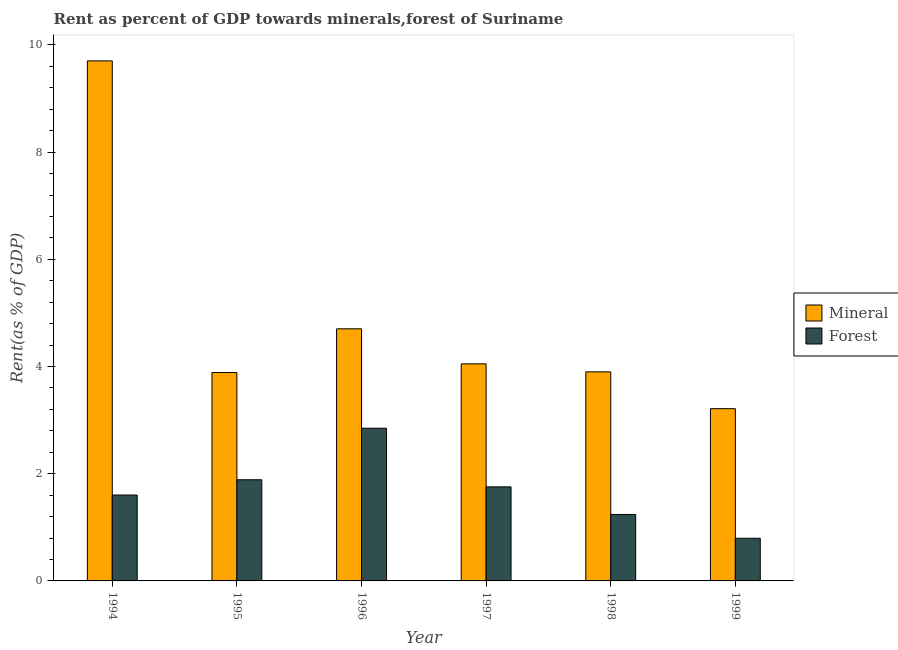How many different coloured bars are there?
Provide a succinct answer. 2. Are the number of bars per tick equal to the number of legend labels?
Your response must be concise. Yes. Are the number of bars on each tick of the X-axis equal?
Provide a succinct answer. Yes. How many bars are there on the 5th tick from the left?
Offer a very short reply. 2. How many bars are there on the 5th tick from the right?
Provide a short and direct response. 2. In how many cases, is the number of bars for a given year not equal to the number of legend labels?
Your response must be concise. 0. What is the forest rent in 1997?
Provide a short and direct response. 1.75. Across all years, what is the maximum mineral rent?
Your answer should be very brief. 9.7. Across all years, what is the minimum mineral rent?
Provide a succinct answer. 3.21. In which year was the forest rent minimum?
Your answer should be very brief. 1999. What is the total forest rent in the graph?
Offer a terse response. 10.13. What is the difference between the mineral rent in 1998 and that in 1999?
Give a very brief answer. 0.69. What is the difference between the forest rent in 1994 and the mineral rent in 1996?
Your answer should be very brief. -1.25. What is the average forest rent per year?
Your answer should be very brief. 1.69. In the year 1999, what is the difference between the forest rent and mineral rent?
Your answer should be compact. 0. What is the ratio of the forest rent in 1997 to that in 1999?
Provide a succinct answer. 2.2. What is the difference between the highest and the second highest mineral rent?
Ensure brevity in your answer.  5. What is the difference between the highest and the lowest forest rent?
Your answer should be very brief. 2.05. In how many years, is the mineral rent greater than the average mineral rent taken over all years?
Provide a short and direct response. 1. Is the sum of the mineral rent in 1995 and 1996 greater than the maximum forest rent across all years?
Your response must be concise. No. What does the 2nd bar from the left in 1998 represents?
Your response must be concise. Forest. What does the 1st bar from the right in 1994 represents?
Your answer should be very brief. Forest. How many bars are there?
Offer a very short reply. 12. Where does the legend appear in the graph?
Ensure brevity in your answer.  Center right. What is the title of the graph?
Make the answer very short. Rent as percent of GDP towards minerals,forest of Suriname. What is the label or title of the Y-axis?
Provide a short and direct response. Rent(as % of GDP). What is the Rent(as % of GDP) of Mineral in 1994?
Ensure brevity in your answer.  9.7. What is the Rent(as % of GDP) of Forest in 1994?
Provide a succinct answer. 1.6. What is the Rent(as % of GDP) of Mineral in 1995?
Ensure brevity in your answer.  3.89. What is the Rent(as % of GDP) in Forest in 1995?
Ensure brevity in your answer.  1.89. What is the Rent(as % of GDP) in Mineral in 1996?
Provide a succinct answer. 4.7. What is the Rent(as % of GDP) of Forest in 1996?
Make the answer very short. 2.85. What is the Rent(as % of GDP) in Mineral in 1997?
Ensure brevity in your answer.  4.05. What is the Rent(as % of GDP) of Forest in 1997?
Ensure brevity in your answer.  1.75. What is the Rent(as % of GDP) of Mineral in 1998?
Provide a short and direct response. 3.9. What is the Rent(as % of GDP) in Forest in 1998?
Provide a succinct answer. 1.24. What is the Rent(as % of GDP) of Mineral in 1999?
Provide a succinct answer. 3.21. What is the Rent(as % of GDP) in Forest in 1999?
Your response must be concise. 0.8. Across all years, what is the maximum Rent(as % of GDP) of Mineral?
Offer a very short reply. 9.7. Across all years, what is the maximum Rent(as % of GDP) of Forest?
Offer a terse response. 2.85. Across all years, what is the minimum Rent(as % of GDP) in Mineral?
Your answer should be compact. 3.21. Across all years, what is the minimum Rent(as % of GDP) of Forest?
Make the answer very short. 0.8. What is the total Rent(as % of GDP) in Mineral in the graph?
Keep it short and to the point. 29.46. What is the total Rent(as % of GDP) of Forest in the graph?
Keep it short and to the point. 10.13. What is the difference between the Rent(as % of GDP) of Mineral in 1994 and that in 1995?
Make the answer very short. 5.82. What is the difference between the Rent(as % of GDP) of Forest in 1994 and that in 1995?
Keep it short and to the point. -0.28. What is the difference between the Rent(as % of GDP) of Mineral in 1994 and that in 1996?
Provide a succinct answer. 5. What is the difference between the Rent(as % of GDP) of Forest in 1994 and that in 1996?
Your answer should be very brief. -1.25. What is the difference between the Rent(as % of GDP) of Mineral in 1994 and that in 1997?
Your response must be concise. 5.65. What is the difference between the Rent(as % of GDP) in Forest in 1994 and that in 1997?
Provide a short and direct response. -0.15. What is the difference between the Rent(as % of GDP) of Mineral in 1994 and that in 1998?
Your answer should be very brief. 5.8. What is the difference between the Rent(as % of GDP) in Forest in 1994 and that in 1998?
Your answer should be very brief. 0.36. What is the difference between the Rent(as % of GDP) of Mineral in 1994 and that in 1999?
Your answer should be very brief. 6.49. What is the difference between the Rent(as % of GDP) in Forest in 1994 and that in 1999?
Offer a very short reply. 0.81. What is the difference between the Rent(as % of GDP) in Mineral in 1995 and that in 1996?
Your answer should be compact. -0.82. What is the difference between the Rent(as % of GDP) of Forest in 1995 and that in 1996?
Offer a terse response. -0.96. What is the difference between the Rent(as % of GDP) of Mineral in 1995 and that in 1997?
Offer a very short reply. -0.16. What is the difference between the Rent(as % of GDP) of Forest in 1995 and that in 1997?
Your answer should be very brief. 0.13. What is the difference between the Rent(as % of GDP) of Mineral in 1995 and that in 1998?
Your response must be concise. -0.01. What is the difference between the Rent(as % of GDP) in Forest in 1995 and that in 1998?
Make the answer very short. 0.65. What is the difference between the Rent(as % of GDP) in Mineral in 1995 and that in 1999?
Provide a short and direct response. 0.67. What is the difference between the Rent(as % of GDP) in Forest in 1995 and that in 1999?
Your response must be concise. 1.09. What is the difference between the Rent(as % of GDP) in Mineral in 1996 and that in 1997?
Make the answer very short. 0.65. What is the difference between the Rent(as % of GDP) in Forest in 1996 and that in 1997?
Provide a succinct answer. 1.09. What is the difference between the Rent(as % of GDP) of Mineral in 1996 and that in 1998?
Your answer should be compact. 0.8. What is the difference between the Rent(as % of GDP) in Forest in 1996 and that in 1998?
Provide a short and direct response. 1.61. What is the difference between the Rent(as % of GDP) of Mineral in 1996 and that in 1999?
Make the answer very short. 1.49. What is the difference between the Rent(as % of GDP) of Forest in 1996 and that in 1999?
Keep it short and to the point. 2.05. What is the difference between the Rent(as % of GDP) in Mineral in 1997 and that in 1998?
Keep it short and to the point. 0.15. What is the difference between the Rent(as % of GDP) of Forest in 1997 and that in 1998?
Offer a very short reply. 0.51. What is the difference between the Rent(as % of GDP) of Mineral in 1997 and that in 1999?
Provide a short and direct response. 0.84. What is the difference between the Rent(as % of GDP) of Forest in 1997 and that in 1999?
Ensure brevity in your answer.  0.96. What is the difference between the Rent(as % of GDP) of Mineral in 1998 and that in 1999?
Provide a short and direct response. 0.69. What is the difference between the Rent(as % of GDP) in Forest in 1998 and that in 1999?
Your answer should be compact. 0.44. What is the difference between the Rent(as % of GDP) of Mineral in 1994 and the Rent(as % of GDP) of Forest in 1995?
Your answer should be compact. 7.82. What is the difference between the Rent(as % of GDP) of Mineral in 1994 and the Rent(as % of GDP) of Forest in 1996?
Give a very brief answer. 6.85. What is the difference between the Rent(as % of GDP) of Mineral in 1994 and the Rent(as % of GDP) of Forest in 1997?
Your response must be concise. 7.95. What is the difference between the Rent(as % of GDP) of Mineral in 1994 and the Rent(as % of GDP) of Forest in 1998?
Offer a terse response. 8.46. What is the difference between the Rent(as % of GDP) of Mineral in 1994 and the Rent(as % of GDP) of Forest in 1999?
Offer a very short reply. 8.91. What is the difference between the Rent(as % of GDP) in Mineral in 1995 and the Rent(as % of GDP) in Forest in 1996?
Your response must be concise. 1.04. What is the difference between the Rent(as % of GDP) in Mineral in 1995 and the Rent(as % of GDP) in Forest in 1997?
Your response must be concise. 2.13. What is the difference between the Rent(as % of GDP) of Mineral in 1995 and the Rent(as % of GDP) of Forest in 1998?
Provide a succinct answer. 2.65. What is the difference between the Rent(as % of GDP) of Mineral in 1995 and the Rent(as % of GDP) of Forest in 1999?
Ensure brevity in your answer.  3.09. What is the difference between the Rent(as % of GDP) of Mineral in 1996 and the Rent(as % of GDP) of Forest in 1997?
Offer a very short reply. 2.95. What is the difference between the Rent(as % of GDP) of Mineral in 1996 and the Rent(as % of GDP) of Forest in 1998?
Offer a terse response. 3.46. What is the difference between the Rent(as % of GDP) in Mineral in 1996 and the Rent(as % of GDP) in Forest in 1999?
Your answer should be very brief. 3.91. What is the difference between the Rent(as % of GDP) in Mineral in 1997 and the Rent(as % of GDP) in Forest in 1998?
Offer a very short reply. 2.81. What is the difference between the Rent(as % of GDP) in Mineral in 1997 and the Rent(as % of GDP) in Forest in 1999?
Your response must be concise. 3.25. What is the difference between the Rent(as % of GDP) of Mineral in 1998 and the Rent(as % of GDP) of Forest in 1999?
Make the answer very short. 3.11. What is the average Rent(as % of GDP) of Mineral per year?
Ensure brevity in your answer.  4.91. What is the average Rent(as % of GDP) in Forest per year?
Offer a very short reply. 1.69. In the year 1994, what is the difference between the Rent(as % of GDP) of Mineral and Rent(as % of GDP) of Forest?
Provide a succinct answer. 8.1. In the year 1995, what is the difference between the Rent(as % of GDP) of Mineral and Rent(as % of GDP) of Forest?
Your response must be concise. 2. In the year 1996, what is the difference between the Rent(as % of GDP) of Mineral and Rent(as % of GDP) of Forest?
Offer a very short reply. 1.85. In the year 1997, what is the difference between the Rent(as % of GDP) in Mineral and Rent(as % of GDP) in Forest?
Provide a short and direct response. 2.3. In the year 1998, what is the difference between the Rent(as % of GDP) in Mineral and Rent(as % of GDP) in Forest?
Provide a succinct answer. 2.66. In the year 1999, what is the difference between the Rent(as % of GDP) in Mineral and Rent(as % of GDP) in Forest?
Offer a very short reply. 2.42. What is the ratio of the Rent(as % of GDP) of Mineral in 1994 to that in 1995?
Your answer should be very brief. 2.5. What is the ratio of the Rent(as % of GDP) in Forest in 1994 to that in 1995?
Make the answer very short. 0.85. What is the ratio of the Rent(as % of GDP) of Mineral in 1994 to that in 1996?
Offer a terse response. 2.06. What is the ratio of the Rent(as % of GDP) in Forest in 1994 to that in 1996?
Your answer should be very brief. 0.56. What is the ratio of the Rent(as % of GDP) of Mineral in 1994 to that in 1997?
Make the answer very short. 2.4. What is the ratio of the Rent(as % of GDP) in Forest in 1994 to that in 1997?
Provide a succinct answer. 0.91. What is the ratio of the Rent(as % of GDP) in Mineral in 1994 to that in 1998?
Ensure brevity in your answer.  2.49. What is the ratio of the Rent(as % of GDP) of Forest in 1994 to that in 1998?
Provide a short and direct response. 1.29. What is the ratio of the Rent(as % of GDP) in Mineral in 1994 to that in 1999?
Offer a very short reply. 3.02. What is the ratio of the Rent(as % of GDP) in Forest in 1994 to that in 1999?
Offer a terse response. 2.01. What is the ratio of the Rent(as % of GDP) of Mineral in 1995 to that in 1996?
Offer a very short reply. 0.83. What is the ratio of the Rent(as % of GDP) of Forest in 1995 to that in 1996?
Your answer should be compact. 0.66. What is the ratio of the Rent(as % of GDP) of Forest in 1995 to that in 1997?
Provide a succinct answer. 1.08. What is the ratio of the Rent(as % of GDP) in Forest in 1995 to that in 1998?
Provide a short and direct response. 1.52. What is the ratio of the Rent(as % of GDP) of Mineral in 1995 to that in 1999?
Give a very brief answer. 1.21. What is the ratio of the Rent(as % of GDP) in Forest in 1995 to that in 1999?
Your answer should be compact. 2.37. What is the ratio of the Rent(as % of GDP) in Mineral in 1996 to that in 1997?
Your answer should be very brief. 1.16. What is the ratio of the Rent(as % of GDP) in Forest in 1996 to that in 1997?
Make the answer very short. 1.62. What is the ratio of the Rent(as % of GDP) of Mineral in 1996 to that in 1998?
Provide a succinct answer. 1.21. What is the ratio of the Rent(as % of GDP) in Forest in 1996 to that in 1998?
Your answer should be compact. 2.3. What is the ratio of the Rent(as % of GDP) of Mineral in 1996 to that in 1999?
Your response must be concise. 1.46. What is the ratio of the Rent(as % of GDP) of Forest in 1996 to that in 1999?
Provide a short and direct response. 3.58. What is the ratio of the Rent(as % of GDP) of Mineral in 1997 to that in 1998?
Provide a short and direct response. 1.04. What is the ratio of the Rent(as % of GDP) of Forest in 1997 to that in 1998?
Offer a very short reply. 1.42. What is the ratio of the Rent(as % of GDP) of Mineral in 1997 to that in 1999?
Provide a succinct answer. 1.26. What is the ratio of the Rent(as % of GDP) of Forest in 1997 to that in 1999?
Make the answer very short. 2.2. What is the ratio of the Rent(as % of GDP) in Mineral in 1998 to that in 1999?
Offer a terse response. 1.21. What is the ratio of the Rent(as % of GDP) in Forest in 1998 to that in 1999?
Offer a terse response. 1.56. What is the difference between the highest and the second highest Rent(as % of GDP) in Mineral?
Your answer should be very brief. 5. What is the difference between the highest and the second highest Rent(as % of GDP) of Forest?
Give a very brief answer. 0.96. What is the difference between the highest and the lowest Rent(as % of GDP) in Mineral?
Provide a short and direct response. 6.49. What is the difference between the highest and the lowest Rent(as % of GDP) in Forest?
Your response must be concise. 2.05. 